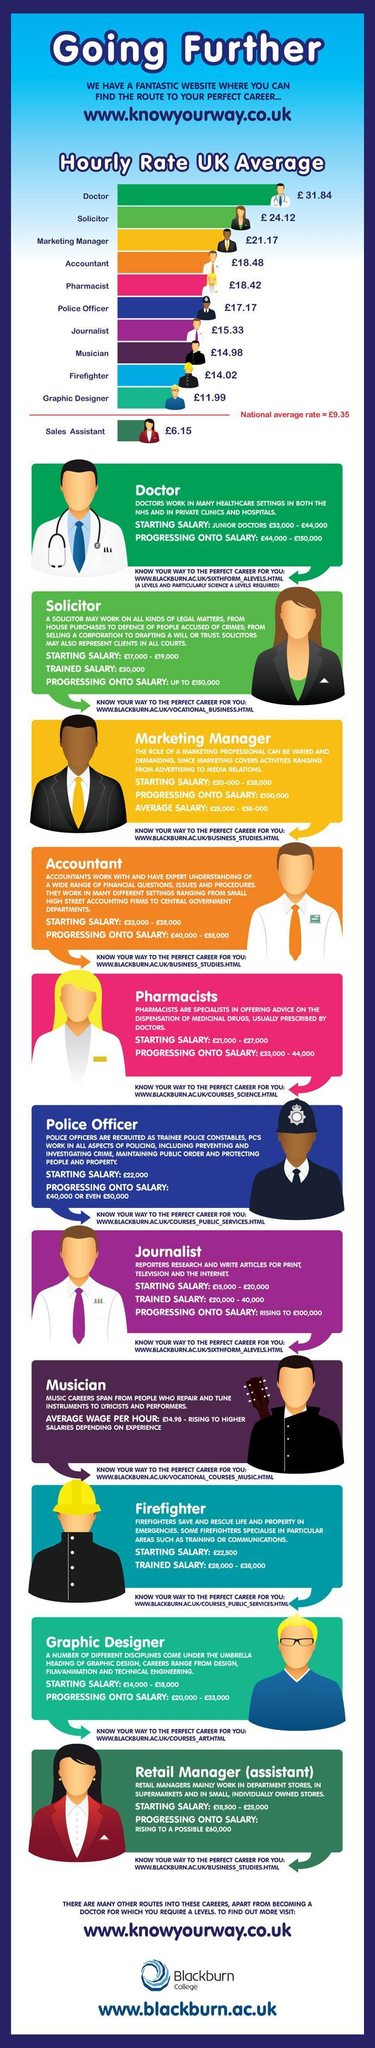Who earns lower than the national average rate ?
Answer the question with a short phrase. Sales assistant Who has a higher 'starting salary' , firefighter or a journalist ? Firefighter Who earns more, a police officer or a  solicitor ? Police officer What colour is used to represent the hourly rate of an accountant - yellow, green or orange ? Orange By how many pounds is the average hourly rate of a pharmacist higher than that of a musician ? 3.44 Who are responsible for dispensing medicinal drugs ? Pharmacists Who receives  salary on hourly wage basis ? Musician Who are responsible for prescribing medicinal drugs ? Doctors What is the upper limit of salary for a doctor who is a novice in his career (in pounds)? 44,000 Upto how much can a veteran solicitor earn (in pounds) ? 150,000 